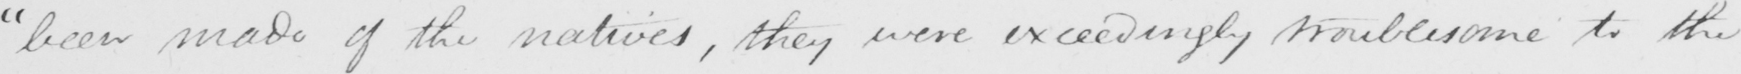Can you read and transcribe this handwriting? " been made of the natives , they were exceedingly troublesome to the 